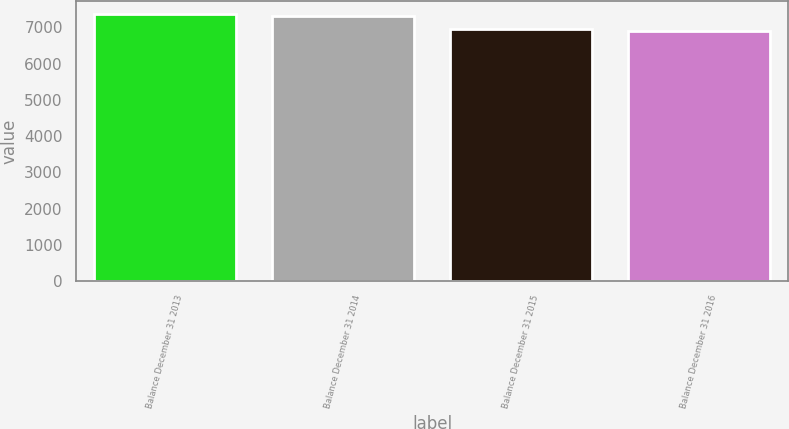<chart> <loc_0><loc_0><loc_500><loc_500><bar_chart><fcel>Balance December 31 2013<fcel>Balance December 31 2014<fcel>Balance December 31 2015<fcel>Balance December 31 2016<nl><fcel>7360.22<fcel>7315.9<fcel>6945.42<fcel>6901.1<nl></chart> 